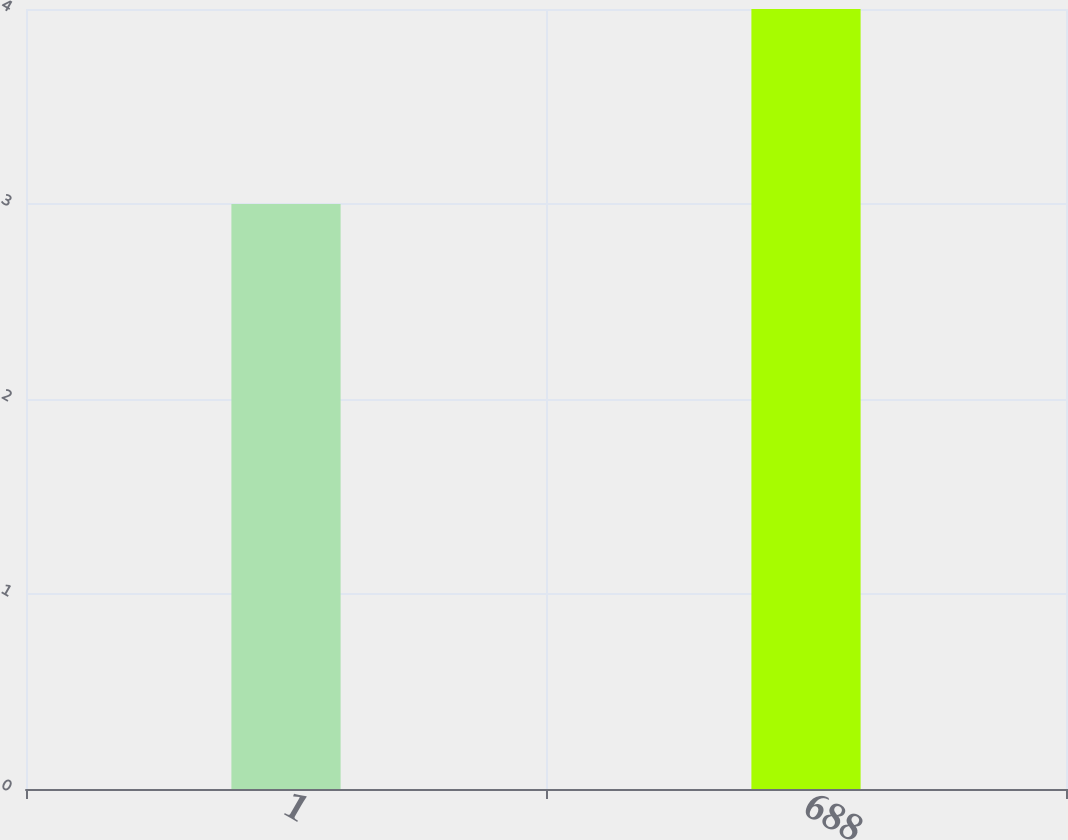Convert chart to OTSL. <chart><loc_0><loc_0><loc_500><loc_500><bar_chart><fcel>1<fcel>688<nl><fcel>3<fcel>4<nl></chart> 